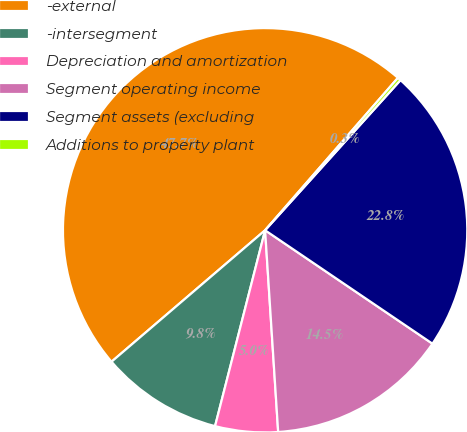<chart> <loc_0><loc_0><loc_500><loc_500><pie_chart><fcel>-external<fcel>-intersegment<fcel>Depreciation and amortization<fcel>Segment operating income<fcel>Segment assets (excluding<fcel>Additions to property plant<nl><fcel>47.67%<fcel>9.75%<fcel>5.01%<fcel>14.49%<fcel>22.8%<fcel>0.27%<nl></chart> 